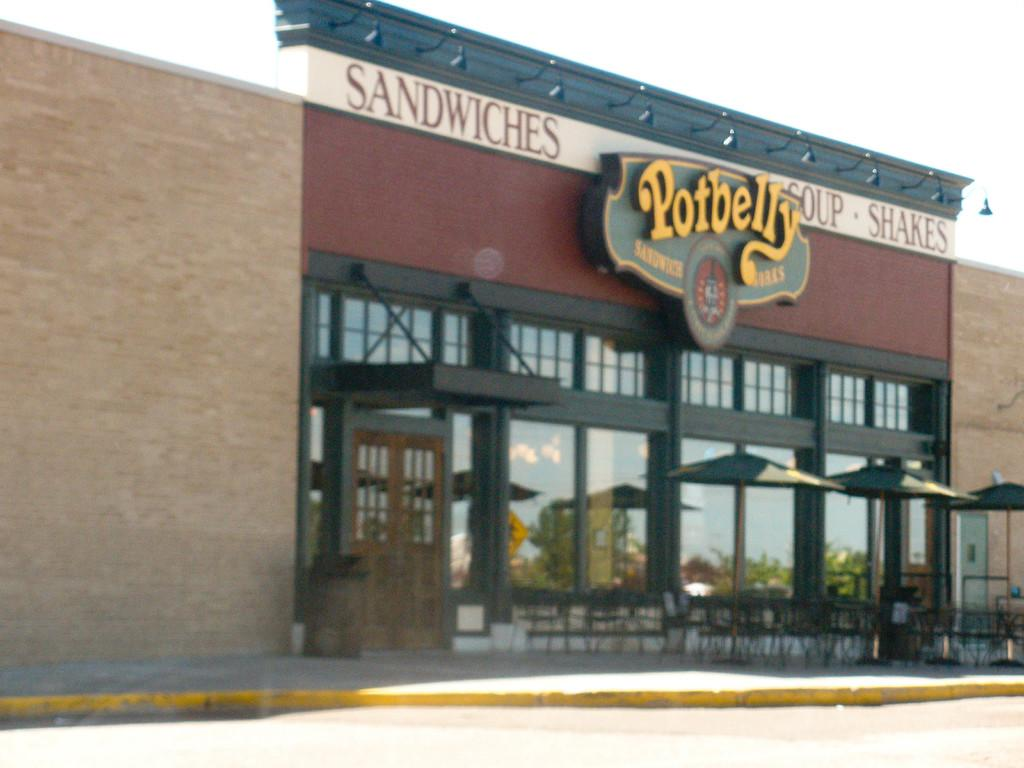What type of structure is visible in the image? There is a building in the image. What is unique about the building's walls? The building has framed glass walls. What type of furniture can be seen in the image? There are chairs in the image. What else can be seen in the image besides the building and chairs? There are other objects in the image. What is visible in the background of the image? The sky is visible in the background of the image. What type of hole can be seen in the building's wall in the image? There is no hole visible in the building's wall in the image. Can you see a guitar being played in the image? There is no guitar or anyone playing a guitar in the image. 